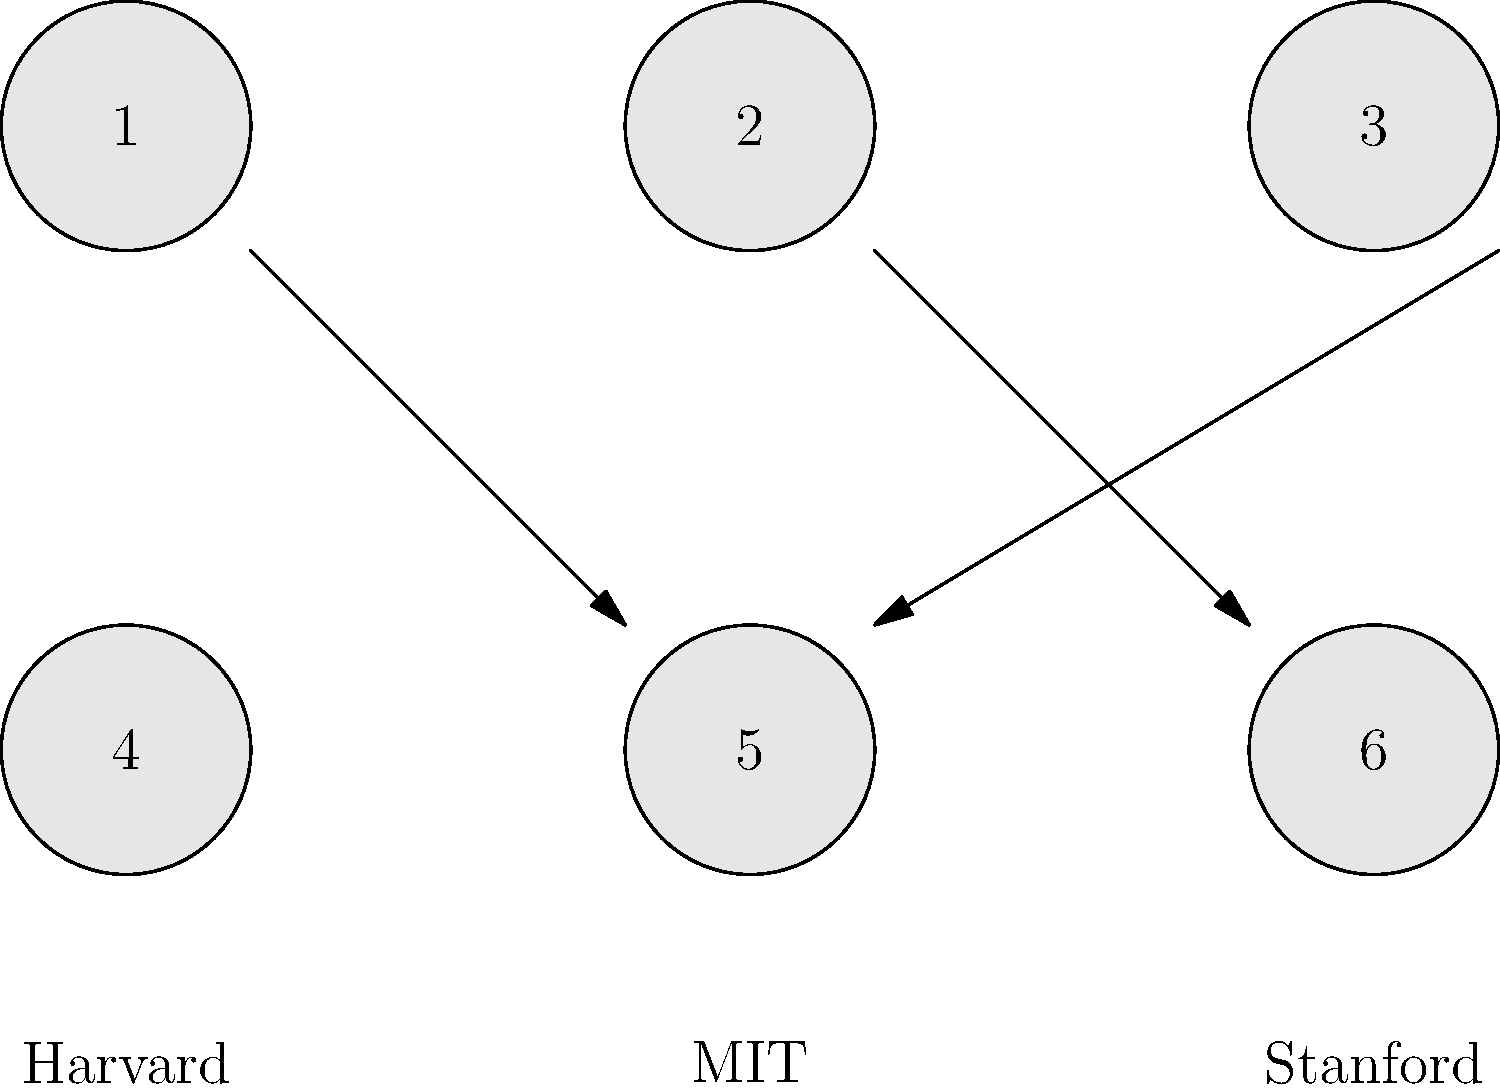Match the academic symbols (numbered 1-6) to their corresponding institutions (Harvard, MIT, Stanford) based on the arrows provided. Which symbol corresponds to MIT? To solve this visual puzzle, we need to follow these steps:

1. Observe the arrangement of symbols and institution names.
2. Note that there are arrows connecting some symbols to institutions.
3. Follow the arrows to determine the correct matches:
   - An arrow connects symbol 1 to Harvard.
   - An arrow connects symbol 2 to MIT.
   - An arrow connects symbol 3 to Stanford.
4. The question specifically asks for the symbol corresponding to MIT.
5. From step 3, we can see that symbol 2 is connected to MIT.

Therefore, the symbol that corresponds to MIT is number 2.
Answer: 2 